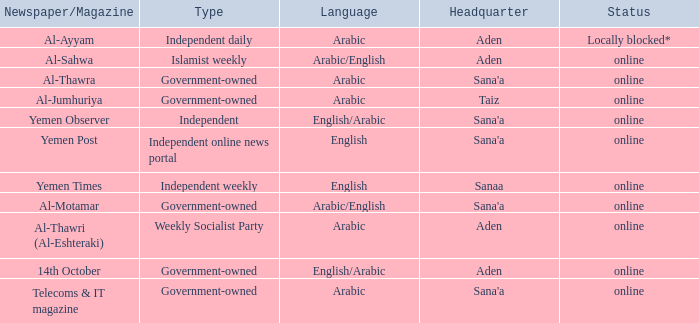Could you parse the entire table? {'header': ['Newspaper/Magazine', 'Type', 'Language', 'Headquarter', 'Status'], 'rows': [['Al-Ayyam', 'Independent daily', 'Arabic', 'Aden', 'Locally blocked*'], ['Al-Sahwa', 'Islamist weekly', 'Arabic/English', 'Aden', 'online'], ['Al-Thawra', 'Government-owned', 'Arabic', "Sana'a", 'online'], ['Al-Jumhuriya', 'Government-owned', 'Arabic', 'Taiz', 'online'], ['Yemen Observer', 'Independent', 'English/Arabic', "Sana'a", 'online'], ['Yemen Post', 'Independent online news portal', 'English', "Sana'a", 'online'], ['Yemen Times', 'Independent weekly', 'English', 'Sanaa', 'online'], ['Al-Motamar', 'Government-owned', 'Arabic/English', "Sana'a", 'online'], ['Al-Thawri (Al-Eshteraki)', 'Weekly Socialist Party', 'Arabic', 'Aden', 'online'], ['14th October', 'Government-owned', 'English/Arabic', 'Aden', 'online'], ['Telecoms & IT magazine', 'Government-owned', 'Arabic', "Sana'a", 'online']]} What is Headquarter, when Type is Independent Online News Portal? Sana'a. 